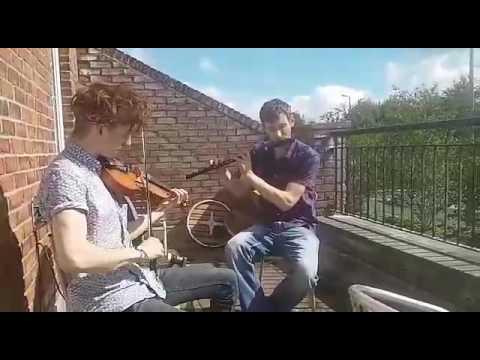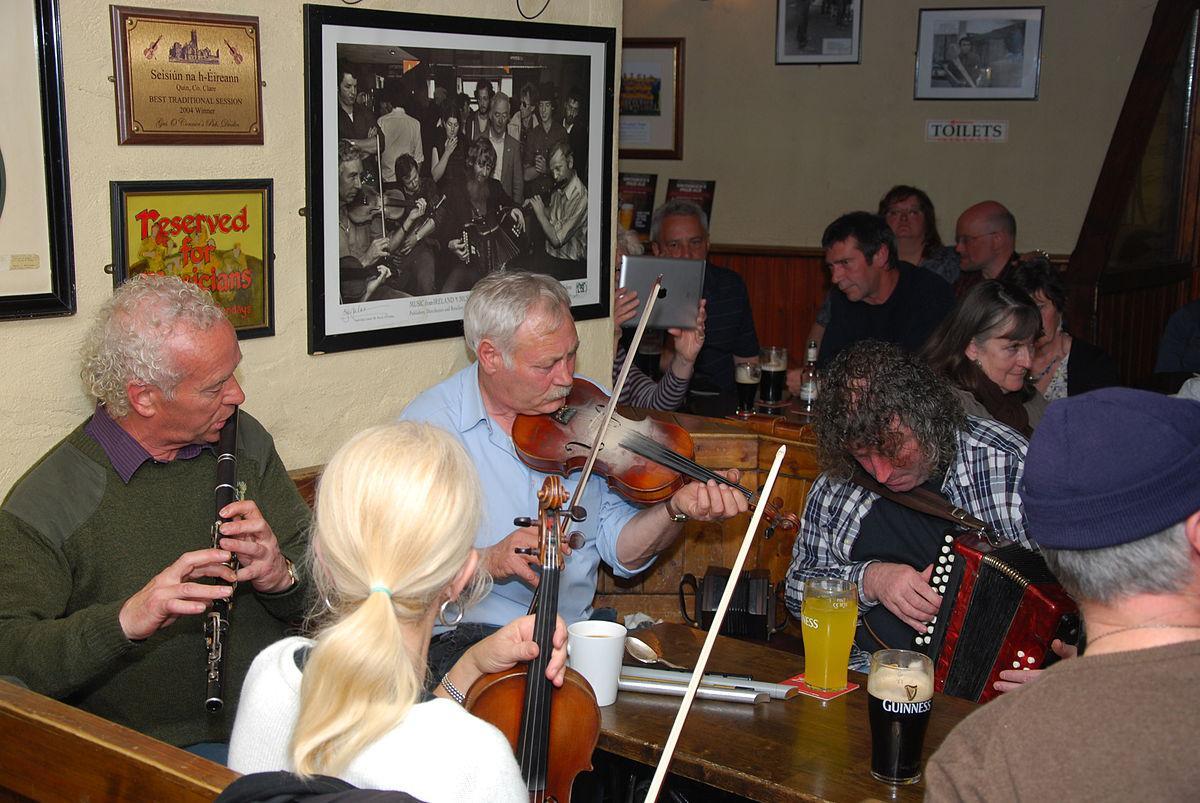The first image is the image on the left, the second image is the image on the right. For the images displayed, is the sentence "There are five people with instruments." factually correct? Answer yes or no. No. The first image is the image on the left, the second image is the image on the right. Examine the images to the left and right. Is the description "Two people are playing the flute." accurate? Answer yes or no. Yes. 